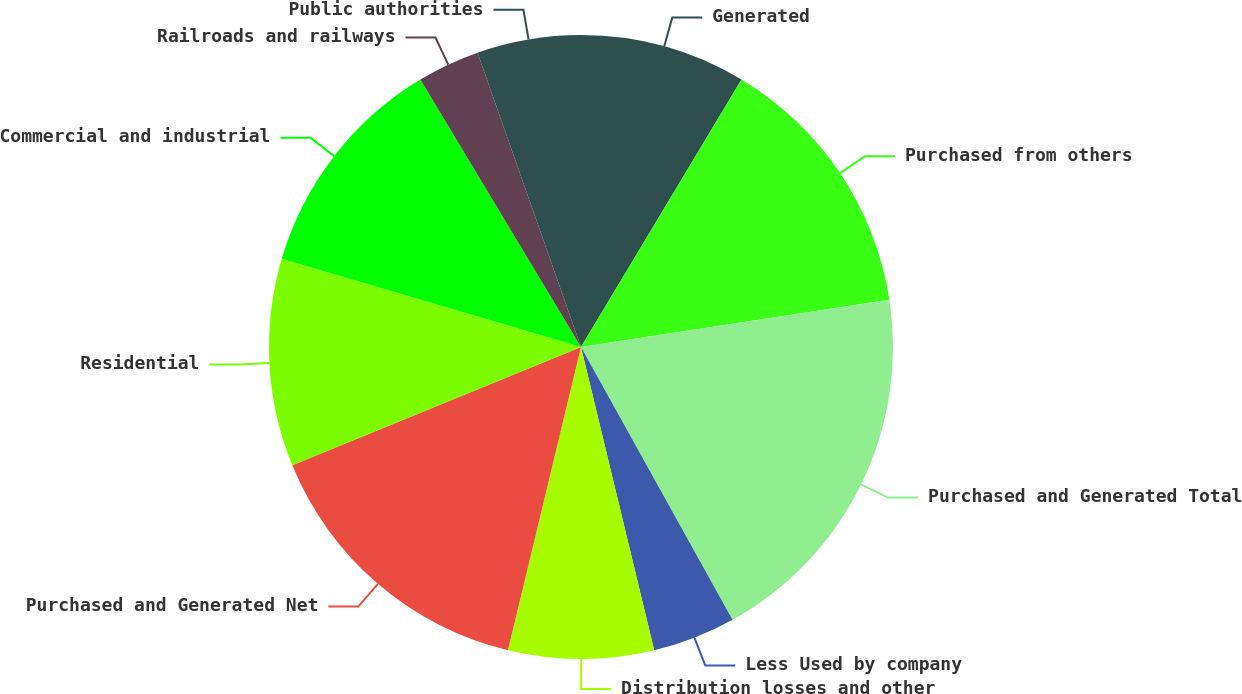Convert chart to OTSL. <chart><loc_0><loc_0><loc_500><loc_500><pie_chart><fcel>Generated<fcel>Purchased from others<fcel>Purchased and Generated Total<fcel>Less Used by company<fcel>Distribution losses and other<fcel>Purchased and Generated Net<fcel>Residential<fcel>Commercial and industrial<fcel>Railroads and railways<fcel>Public authorities<nl><fcel>8.6%<fcel>13.98%<fcel>19.35%<fcel>4.3%<fcel>7.53%<fcel>15.05%<fcel>10.75%<fcel>11.83%<fcel>3.23%<fcel>5.38%<nl></chart> 